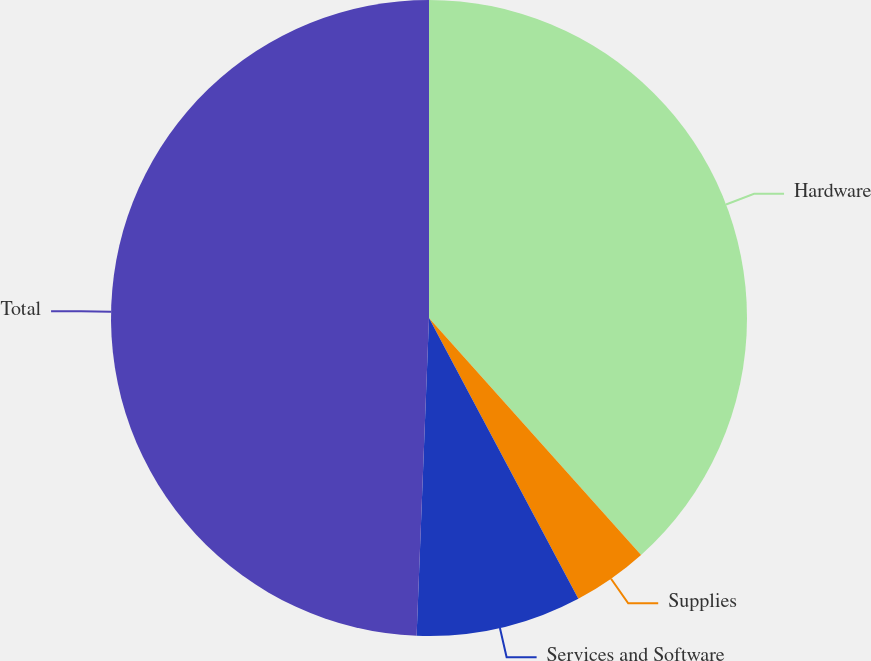Convert chart. <chart><loc_0><loc_0><loc_500><loc_500><pie_chart><fcel>Hardware<fcel>Supplies<fcel>Services and Software<fcel>Total<nl><fcel>38.38%<fcel>3.84%<fcel>8.4%<fcel>49.38%<nl></chart> 